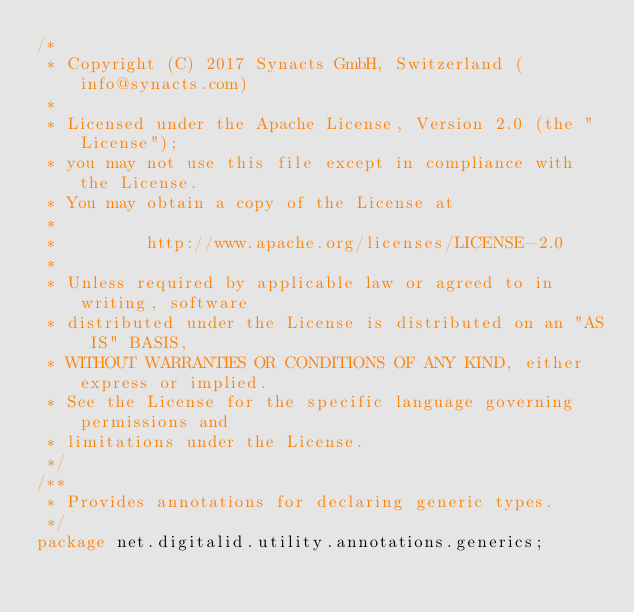Convert code to text. <code><loc_0><loc_0><loc_500><loc_500><_Java_>/*
 * Copyright (C) 2017 Synacts GmbH, Switzerland (info@synacts.com)
 *
 * Licensed under the Apache License, Version 2.0 (the "License");
 * you may not use this file except in compliance with the License.
 * You may obtain a copy of the License at
 *
 *         http://www.apache.org/licenses/LICENSE-2.0
 *
 * Unless required by applicable law or agreed to in writing, software
 * distributed under the License is distributed on an "AS IS" BASIS,
 * WITHOUT WARRANTIES OR CONDITIONS OF ANY KIND, either express or implied.
 * See the License for the specific language governing permissions and
 * limitations under the License.
 */
/**
 * Provides annotations for declaring generic types.
 */
package net.digitalid.utility.annotations.generics;
</code> 